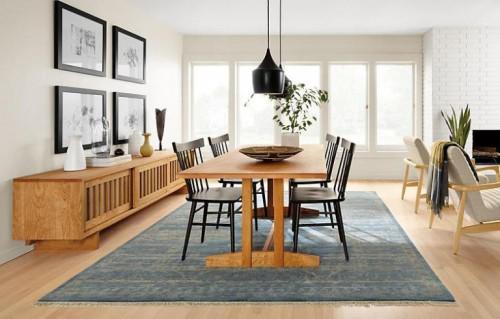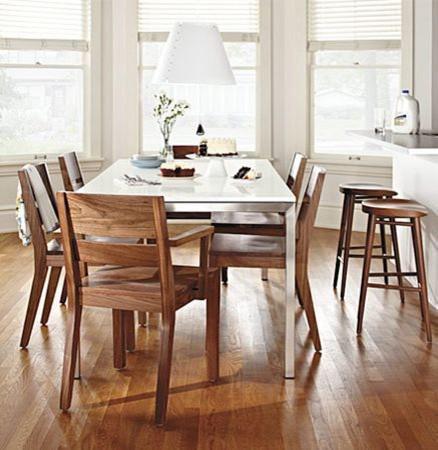The first image is the image on the left, the second image is the image on the right. Given the left and right images, does the statement "A rectangular dining table has at least two chairs on each long side." hold true? Answer yes or no. Yes. The first image is the image on the left, the second image is the image on the right. Analyze the images presented: Is the assertion "In one of the images, there is a dining table and chairs placed over an area rug." valid? Answer yes or no. Yes. 